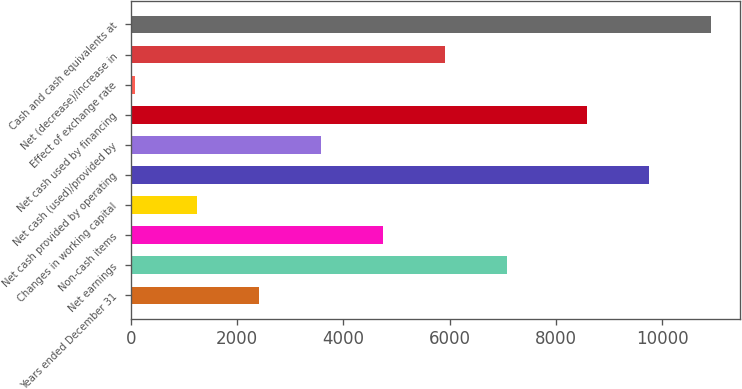Convert chart. <chart><loc_0><loc_0><loc_500><loc_500><bar_chart><fcel>Years ended December 31<fcel>Net earnings<fcel>Non-cash items<fcel>Changes in working capital<fcel>Net cash provided by operating<fcel>Net cash (used)/provided by<fcel>Net cash used by financing<fcel>Effect of exchange rate<fcel>Net (decrease)/increase in<fcel>Cash and cash equivalents at<nl><fcel>2416.2<fcel>7074.6<fcel>4745.4<fcel>1251.6<fcel>9757.6<fcel>3580.8<fcel>8593<fcel>87<fcel>5910<fcel>10922.2<nl></chart> 